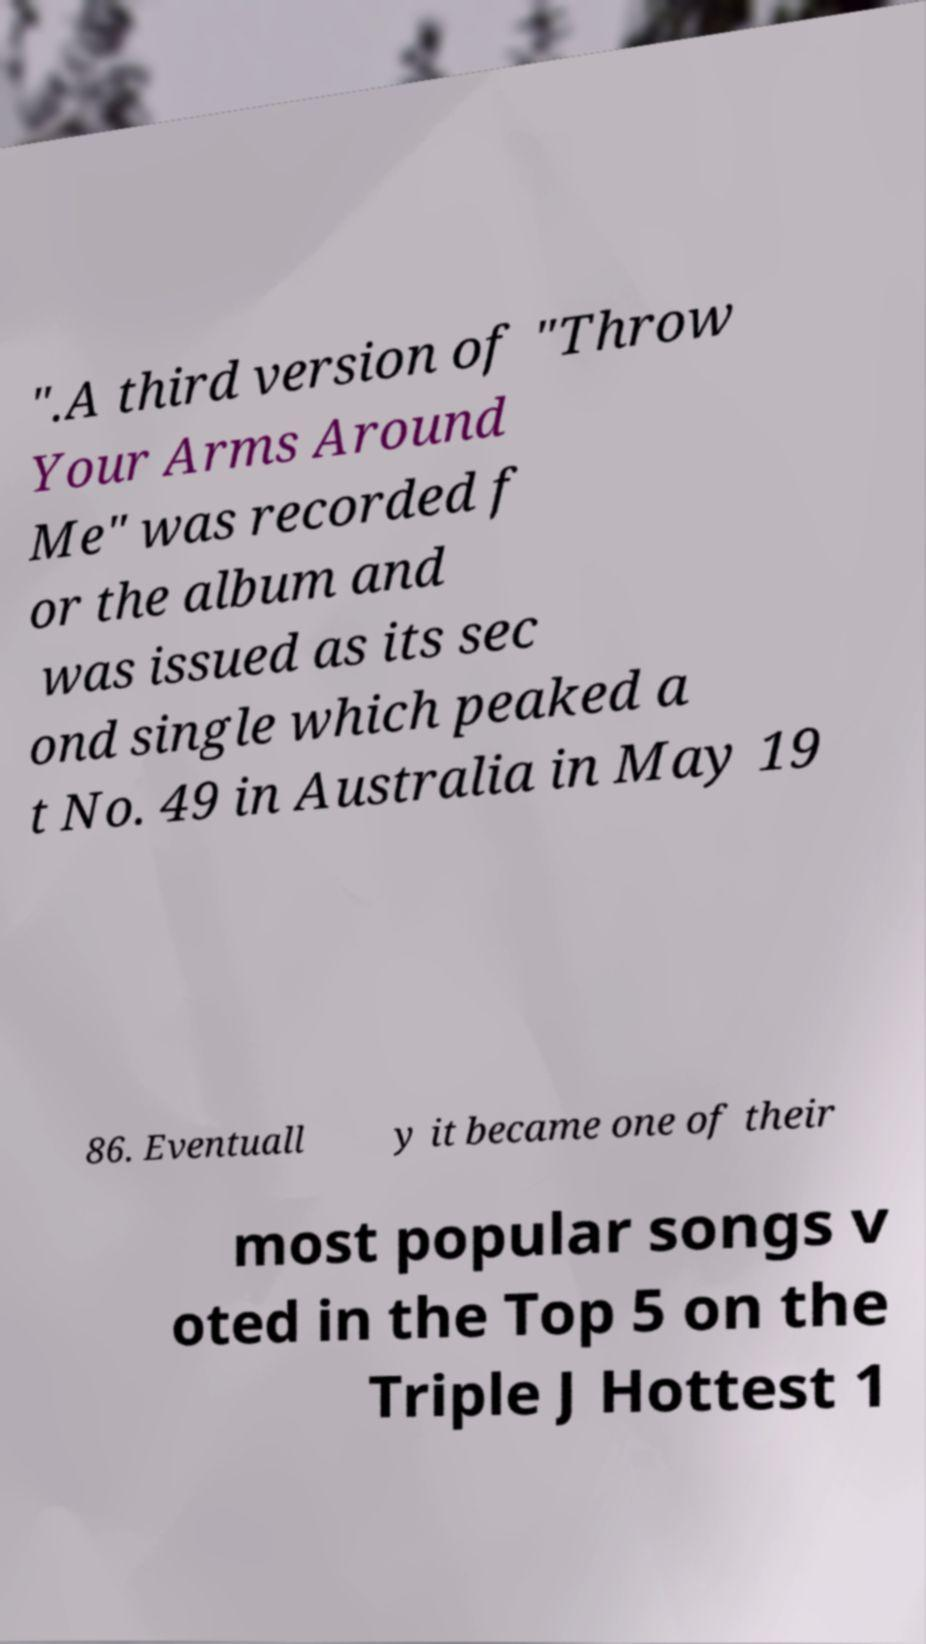Can you read and provide the text displayed in the image?This photo seems to have some interesting text. Can you extract and type it out for me? ".A third version of "Throw Your Arms Around Me" was recorded f or the album and was issued as its sec ond single which peaked a t No. 49 in Australia in May 19 86. Eventuall y it became one of their most popular songs v oted in the Top 5 on the Triple J Hottest 1 